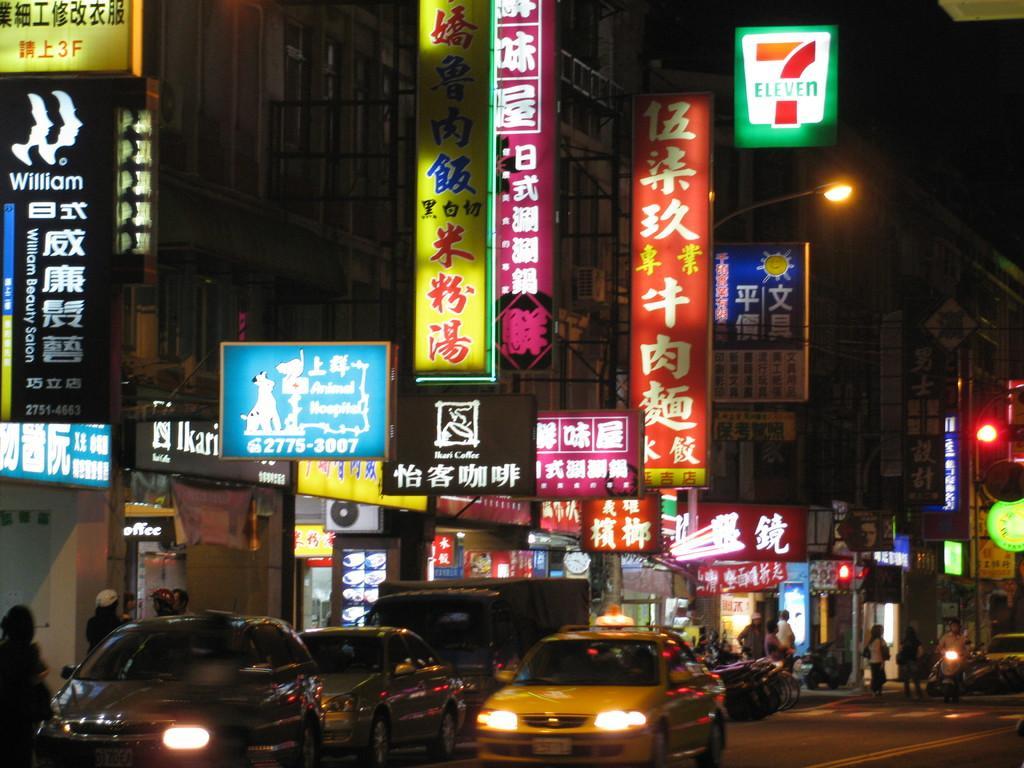Describe this image in one or two sentences. In this picture we can see buildings, posters, banners, advertisement boards and street lights. At the bottom we can see cars and trucks on the road, behind that we can see the bikes. In the bottom right corner we can see a man who is riding a bike, beside him we can see the group of persons were standing in front of the door. 